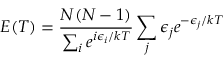Convert formula to latex. <formula><loc_0><loc_0><loc_500><loc_500>E ( T ) = \frac { N ( N - 1 ) } { \sum _ { i } e ^ { i \epsilon _ { i } / k T } } \sum _ { j } \epsilon _ { j } e ^ { - \epsilon _ { j } / k T }</formula> 